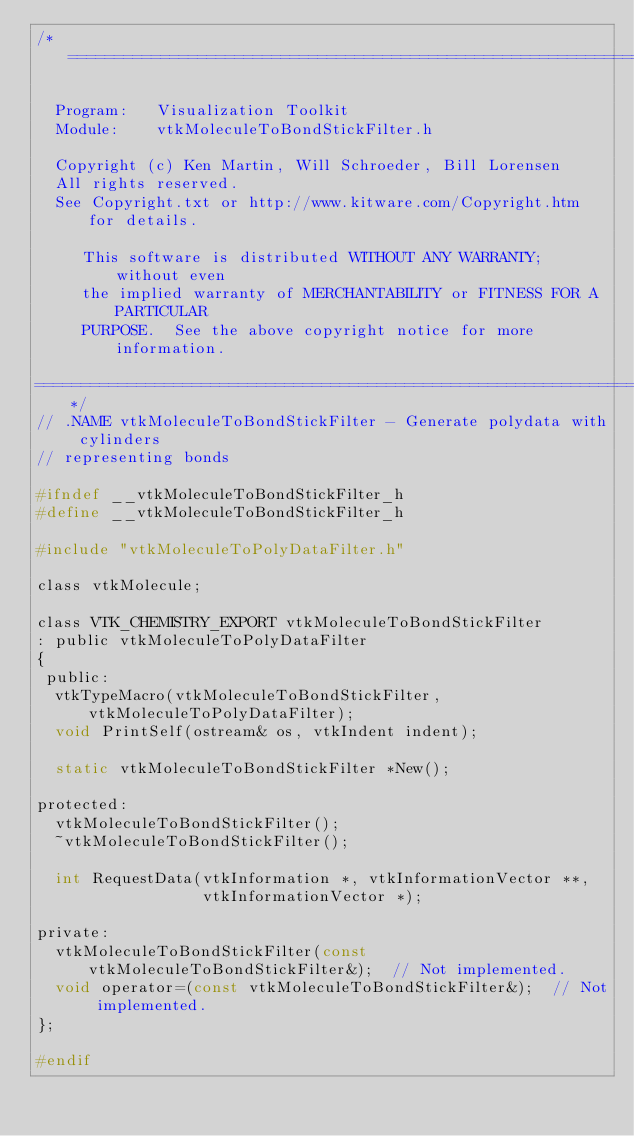<code> <loc_0><loc_0><loc_500><loc_500><_C_>/*=========================================================================

  Program:   Visualization Toolkit
  Module:    vtkMoleculeToBondStickFilter.h

  Copyright (c) Ken Martin, Will Schroeder, Bill Lorensen
  All rights reserved.
  See Copyright.txt or http://www.kitware.com/Copyright.htm for details.

     This software is distributed WITHOUT ANY WARRANTY; without even
     the implied warranty of MERCHANTABILITY or FITNESS FOR A PARTICULAR
     PURPOSE.  See the above copyright notice for more information.

=========================================================================*/
// .NAME vtkMoleculeToBondStickFilter - Generate polydata with cylinders
// representing bonds

#ifndef __vtkMoleculeToBondStickFilter_h
#define __vtkMoleculeToBondStickFilter_h

#include "vtkMoleculeToPolyDataFilter.h"

class vtkMolecule;

class VTK_CHEMISTRY_EXPORT vtkMoleculeToBondStickFilter
: public vtkMoleculeToPolyDataFilter
{
 public:
  vtkTypeMacro(vtkMoleculeToBondStickFilter,vtkMoleculeToPolyDataFilter);
  void PrintSelf(ostream& os, vtkIndent indent);

  static vtkMoleculeToBondStickFilter *New();

protected:
  vtkMoleculeToBondStickFilter();
  ~vtkMoleculeToBondStickFilter();

  int RequestData(vtkInformation *, vtkInformationVector **,
                  vtkInformationVector *);

private:
  vtkMoleculeToBondStickFilter(const vtkMoleculeToBondStickFilter&);  // Not implemented.
  void operator=(const vtkMoleculeToBondStickFilter&);  // Not implemented.
};

#endif
</code> 